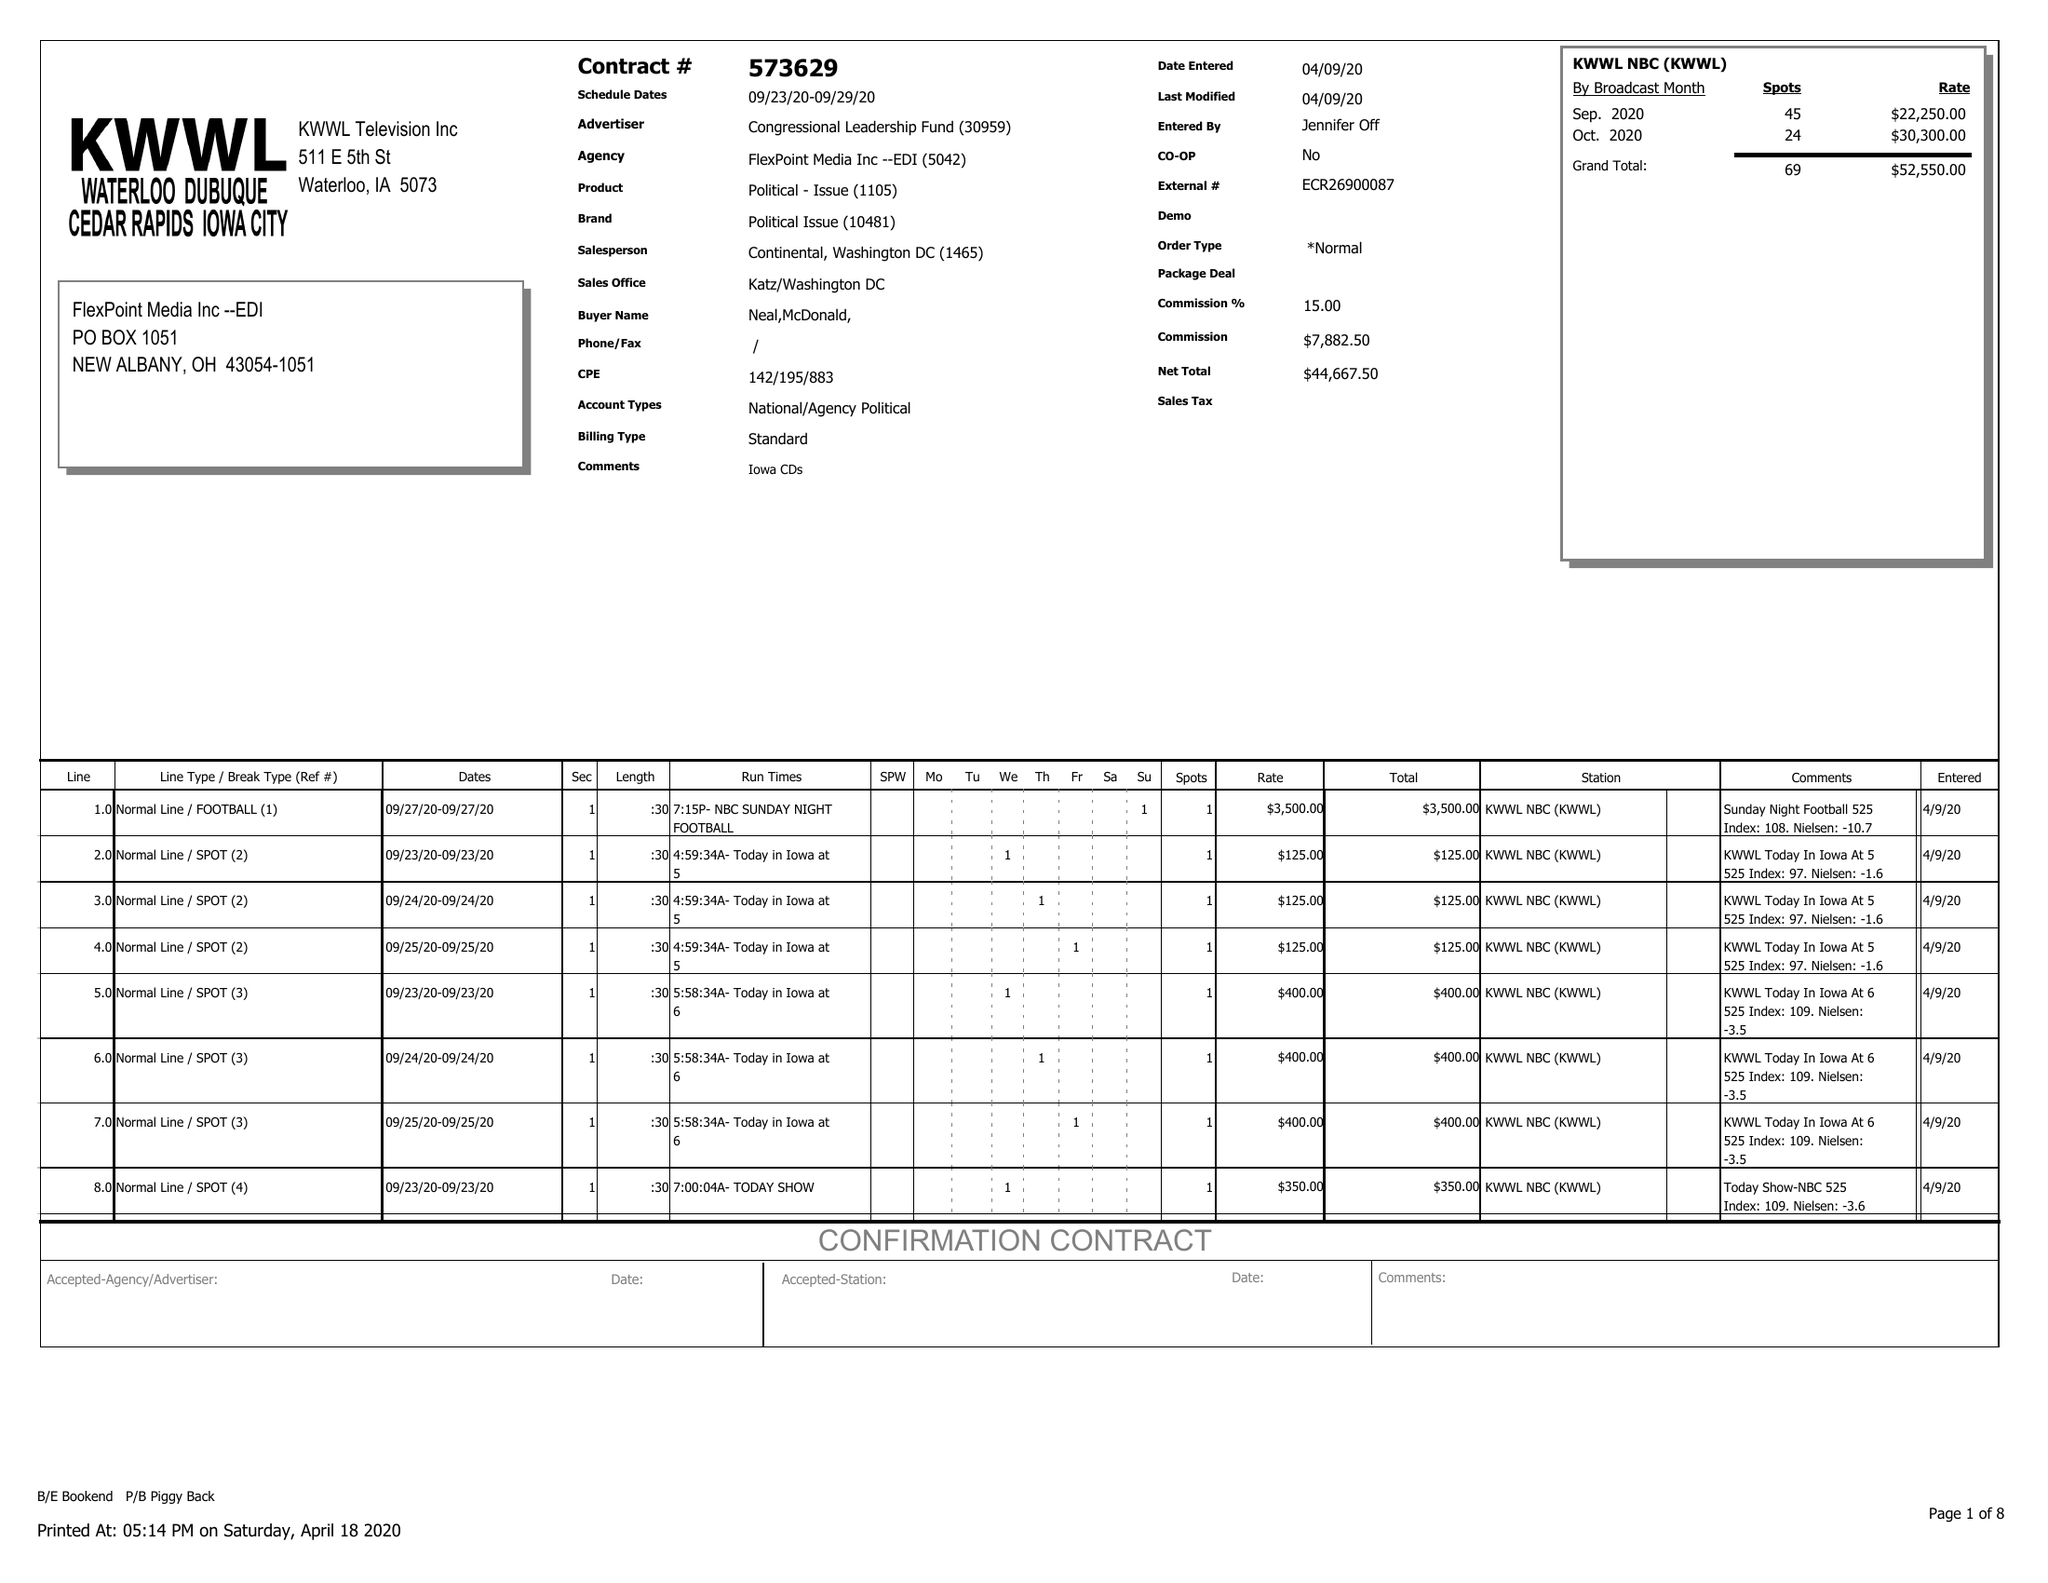What is the value for the contract_num?
Answer the question using a single word or phrase. 573629 